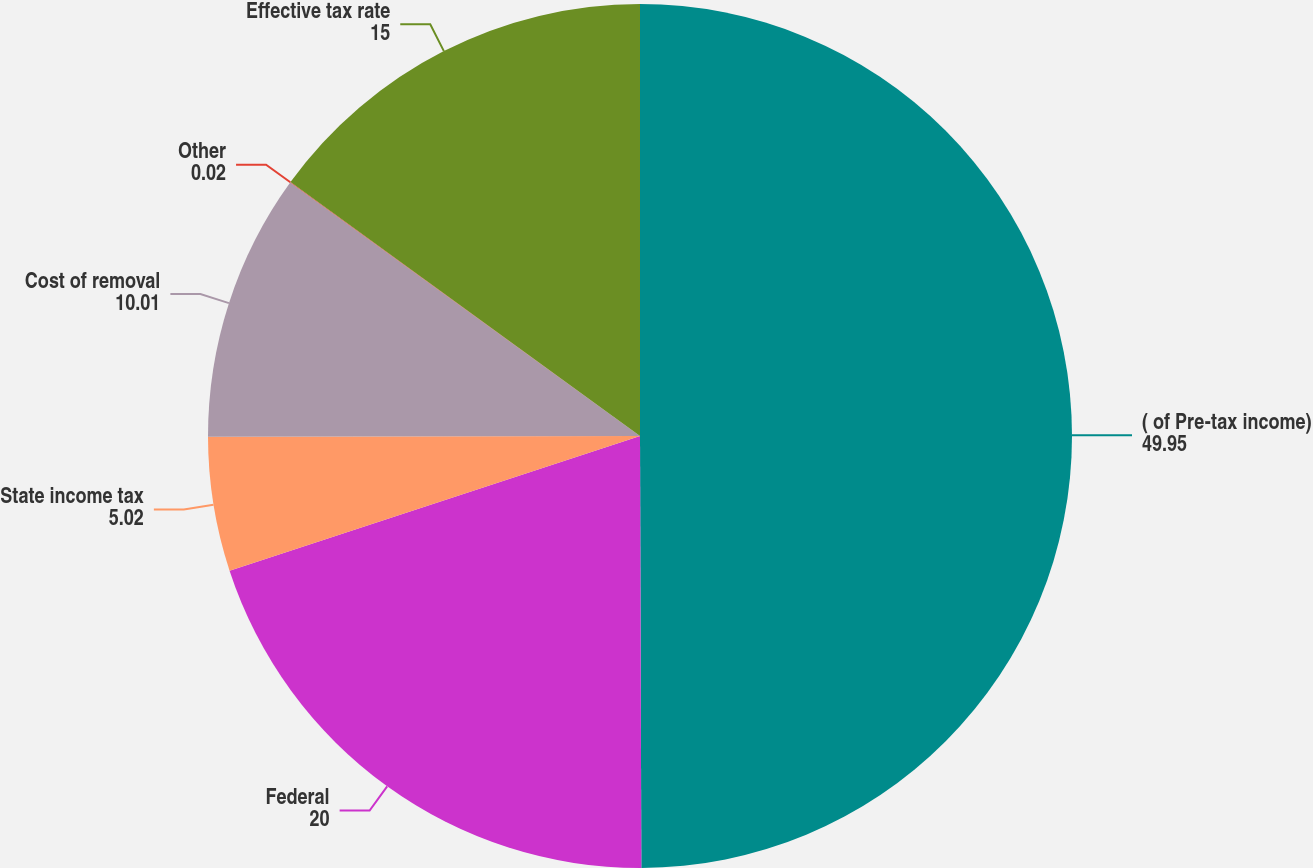<chart> <loc_0><loc_0><loc_500><loc_500><pie_chart><fcel>( of Pre-tax income)<fcel>Federal<fcel>State income tax<fcel>Cost of removal<fcel>Other<fcel>Effective tax rate<nl><fcel>49.95%<fcel>20.0%<fcel>5.02%<fcel>10.01%<fcel>0.02%<fcel>15.0%<nl></chart> 